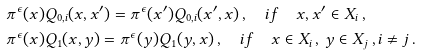<formula> <loc_0><loc_0><loc_500><loc_500>& \pi ^ { \epsilon } ( x ) Q _ { 0 , i } ( x , x ^ { \prime } ) = \pi ^ { \epsilon } ( x ^ { \prime } ) Q _ { 0 , i } ( x ^ { \prime } , x ) \, , \quad i f \quad x , x ^ { \prime } \in X _ { i } \, , \\ & \pi ^ { \epsilon } ( x ) Q _ { 1 } ( x , y ) = \pi ^ { \epsilon } ( y ) Q _ { 1 } ( y , x ) \, , \quad i f \quad x \in X _ { i } \, , \, y \in X _ { j } \, , i \neq j \, .</formula> 